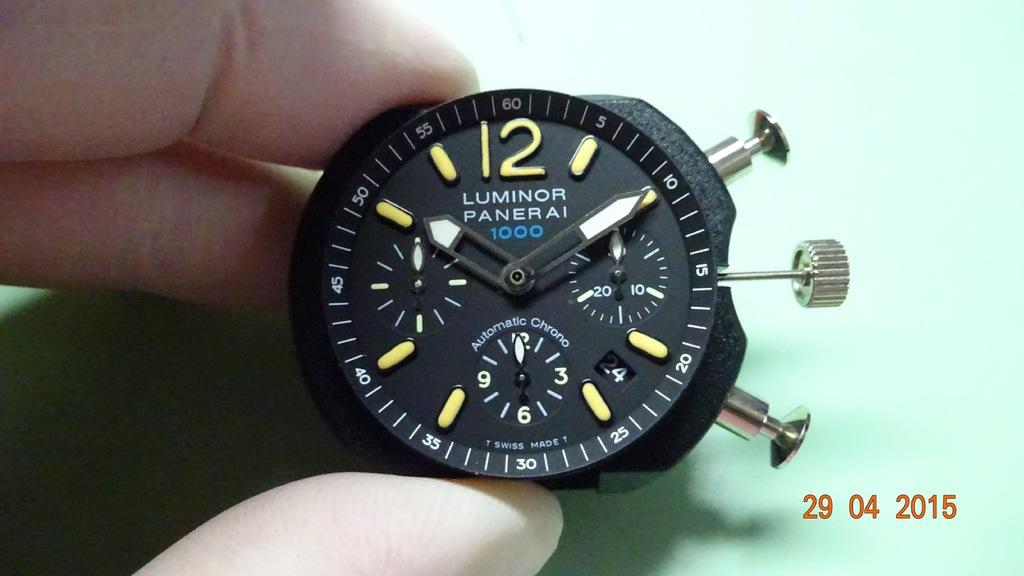Provide a one-sentence caption for the provided image. A Luminor watch displays a black screen and bright green number symbols. 